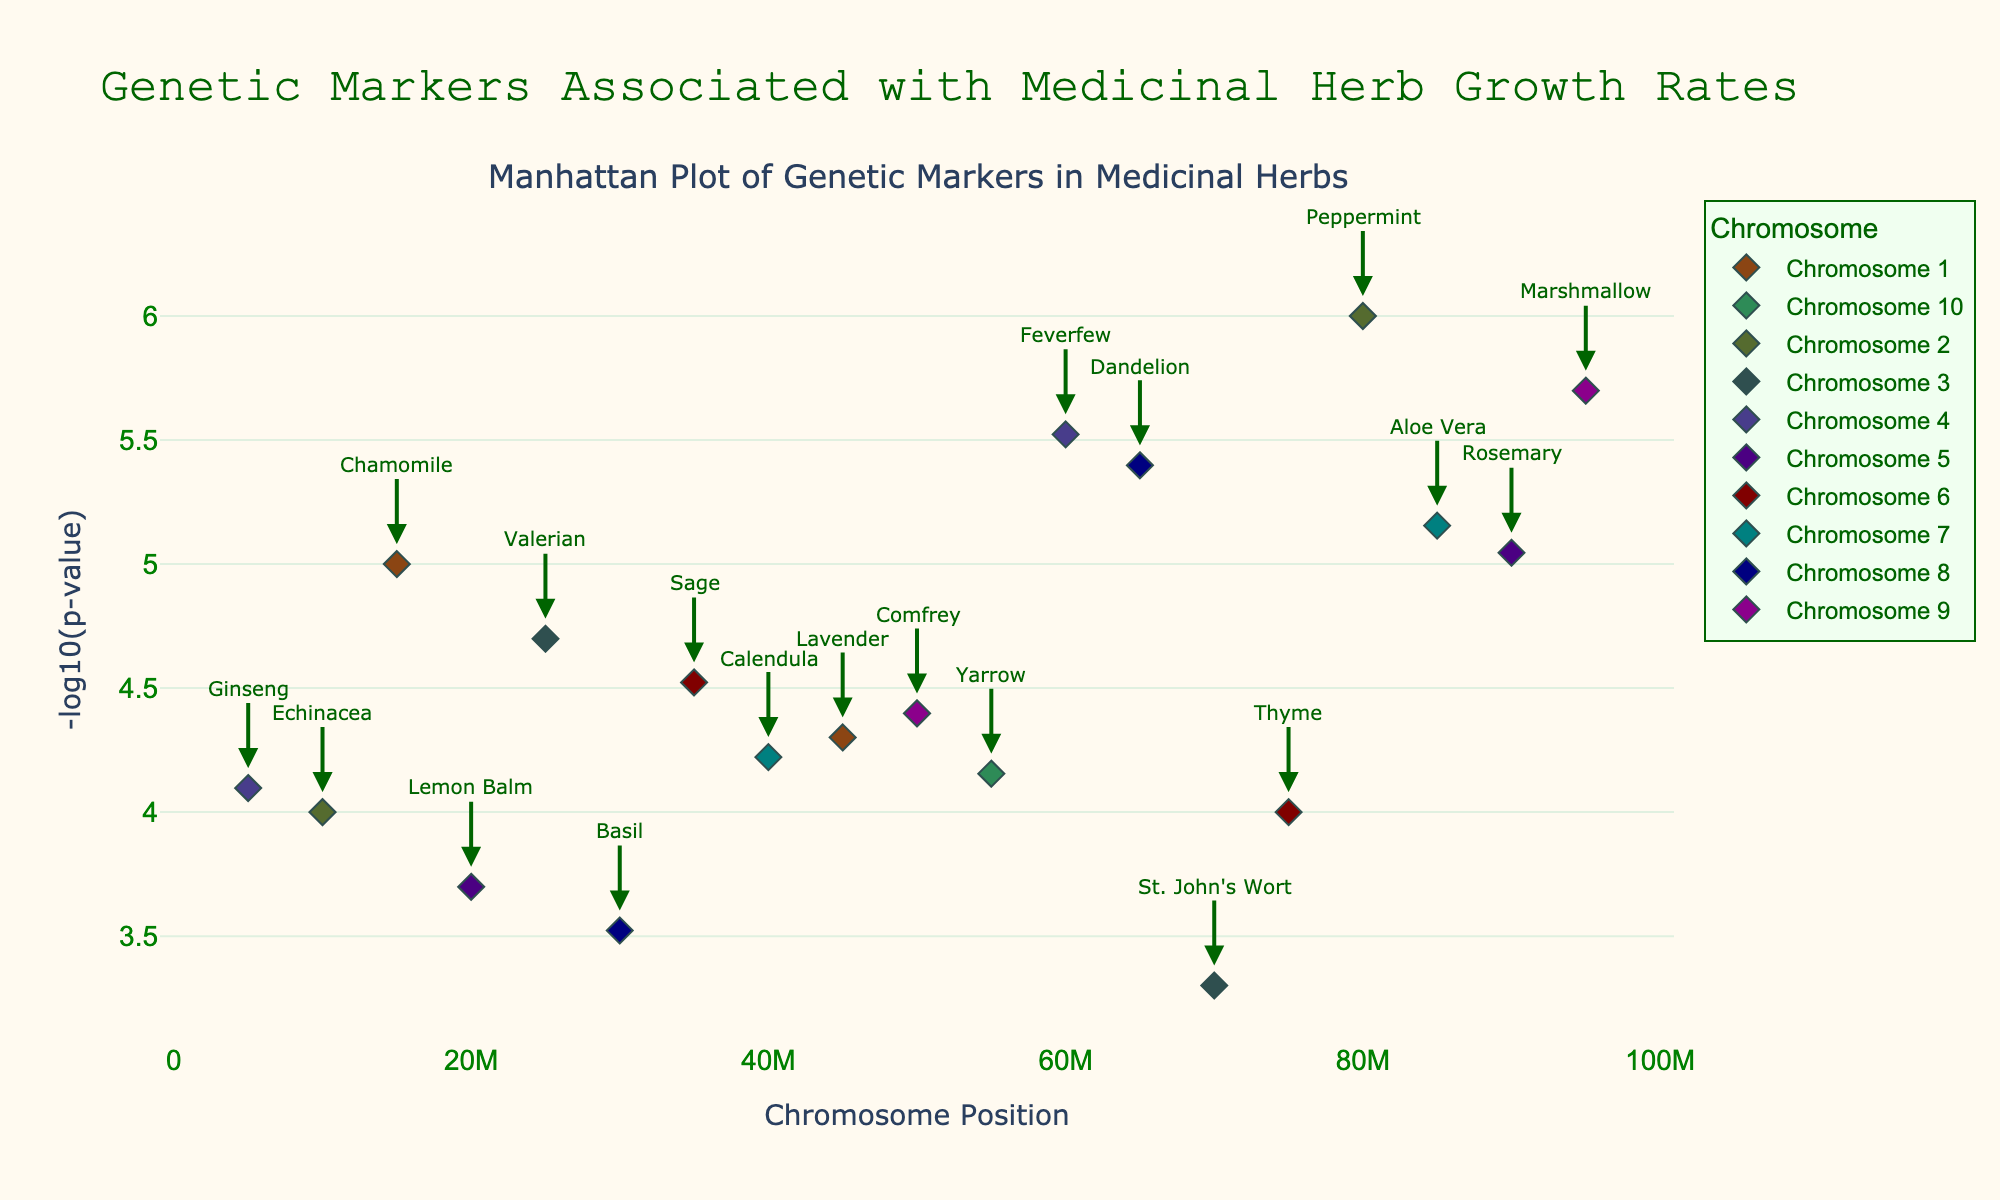What is the title of the plot? The title of the plot is usually located at the top of the figure. In this plot, it reads "Genetic Markers Associated with Medicinal Herb Growth Rates".
Answer: Genetic Markers Associated with Medicinal Herb Growth Rates What do the x-axis and y-axis represent? The x-axis represents the position on the chromosome, while the y-axis shows the -log10(p-value), which measures the significance of the genetic markers.
Answer: Chromosome Position; -log10(p-value) Which herb species is associated with the lowest p-value? The lowest p-value means the highest -log10(p-value) on the y-axis. We look for the herb species at the highest point, which is Peppermint.
Answer: Peppermint How many herb species are represented on chromosome 5? By counting the number of distinct herbs on chromosome 5 from the plot annotations, we see two: Lemon Balm and Rosemary.
Answer: 2 Which chromosome contains the most significant genetic marker for its position? The most significant marker would have the highest -log10(p-value). Chromosome 2, with Peppermint at 80,000,000 position having the highest point.
Answer: Chromosome 2 Compare the significance of genetic markers for St. John's Wort and Calendula. Which one has a lower p-value? To compare, we find the positions of both on the y-axis. St. John's Wort has a marker at 3,700,000 with a -log10(p) of 0.3010, while Calendula at 7,400,000 has -log10(p) of 4.2218. The higher value indicates a lower p-value, so Calendula has a lower p-value.
Answer: Calendula What is the range of significant points (in terms of -log10(p-value)) on chromosome 1? Find the highest and lowest -log10(p)value on chromosome 1. The points are at 4.3010 (Chamomile) and 5.3010 (Lavender). The range is 1.000.
Answer: 1.000 Which herb species on chromosome 4 has the smallest p-value? On chromosome 4, we see two species: Ginseng and Feverfew. Feverfew has a higher -log10(p) at 60,000,000 position, so it has a smaller p-value.
Answer: Feverfew 